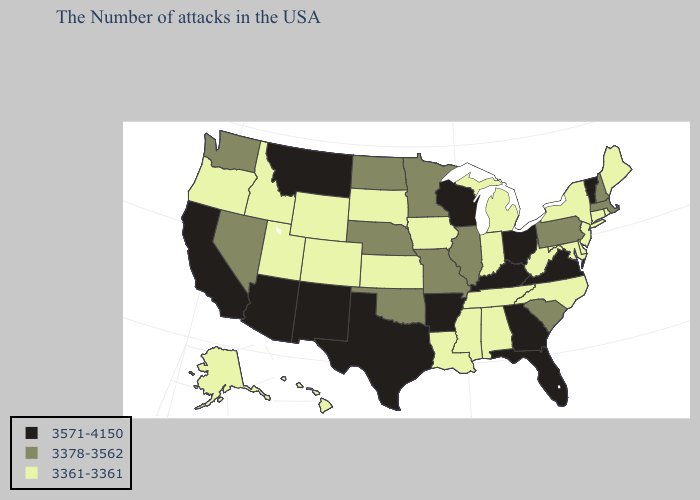What is the lowest value in states that border Arizona?
Keep it brief. 3361-3361. What is the lowest value in states that border Idaho?
Concise answer only. 3361-3361. Does the map have missing data?
Answer briefly. No. Name the states that have a value in the range 3571-4150?
Short answer required. Vermont, Virginia, Ohio, Florida, Georgia, Kentucky, Wisconsin, Arkansas, Texas, New Mexico, Montana, Arizona, California. Name the states that have a value in the range 3361-3361?
Concise answer only. Maine, Rhode Island, Connecticut, New York, New Jersey, Delaware, Maryland, North Carolina, West Virginia, Michigan, Indiana, Alabama, Tennessee, Mississippi, Louisiana, Iowa, Kansas, South Dakota, Wyoming, Colorado, Utah, Idaho, Oregon, Alaska, Hawaii. What is the lowest value in the South?
Concise answer only. 3361-3361. Which states hav the highest value in the Northeast?
Answer briefly. Vermont. What is the lowest value in the West?
Give a very brief answer. 3361-3361. Does Indiana have the lowest value in the MidWest?
Concise answer only. Yes. Among the states that border Indiana , does Michigan have the lowest value?
Keep it brief. Yes. How many symbols are there in the legend?
Give a very brief answer. 3. Does Nevada have the highest value in the West?
Short answer required. No. Name the states that have a value in the range 3571-4150?
Concise answer only. Vermont, Virginia, Ohio, Florida, Georgia, Kentucky, Wisconsin, Arkansas, Texas, New Mexico, Montana, Arizona, California. What is the value of Michigan?
Quick response, please. 3361-3361. Does Virginia have the highest value in the USA?
Concise answer only. Yes. 